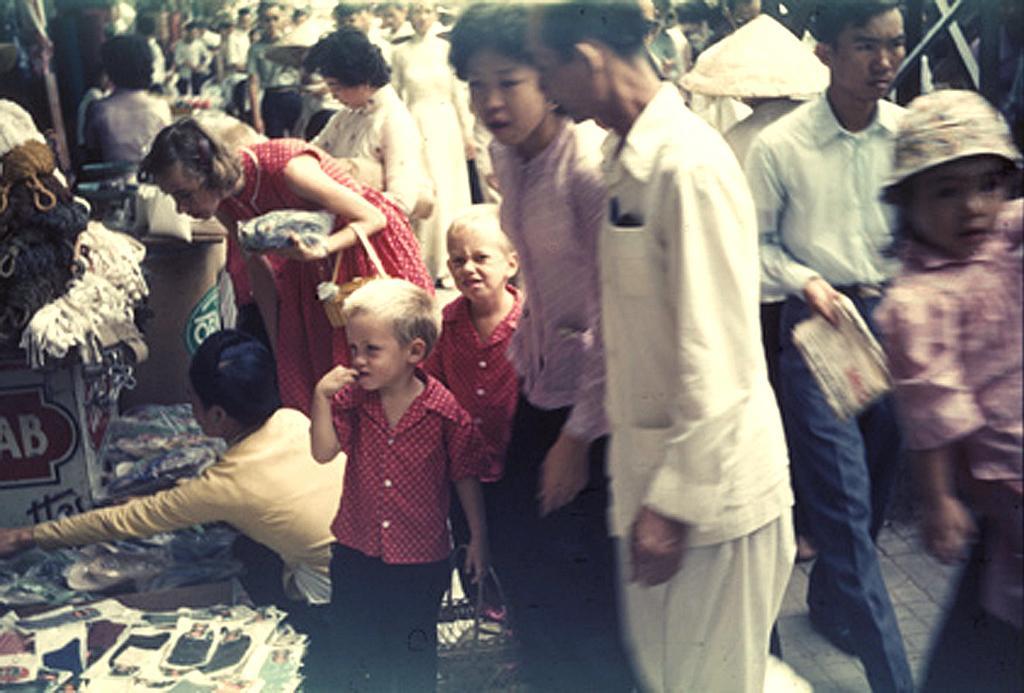Can you describe this image briefly? In this picture there are people in the image and there are stalls on the left side of the image and there are clothes and posters in the image. 